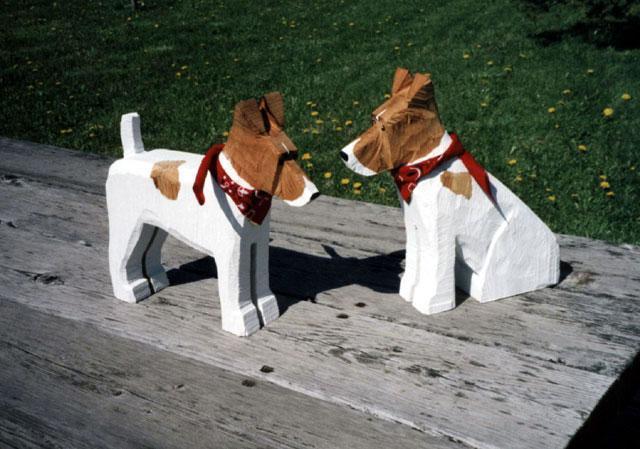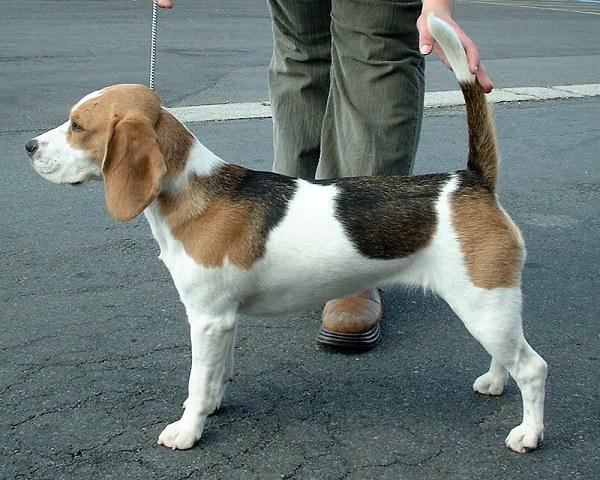The first image is the image on the left, the second image is the image on the right. Given the left and right images, does the statement "There is only one real dog in total." hold true? Answer yes or no. Yes. The first image is the image on the left, the second image is the image on the right. For the images displayed, is the sentence "There are two dog figurines on the left." factually correct? Answer yes or no. Yes. 